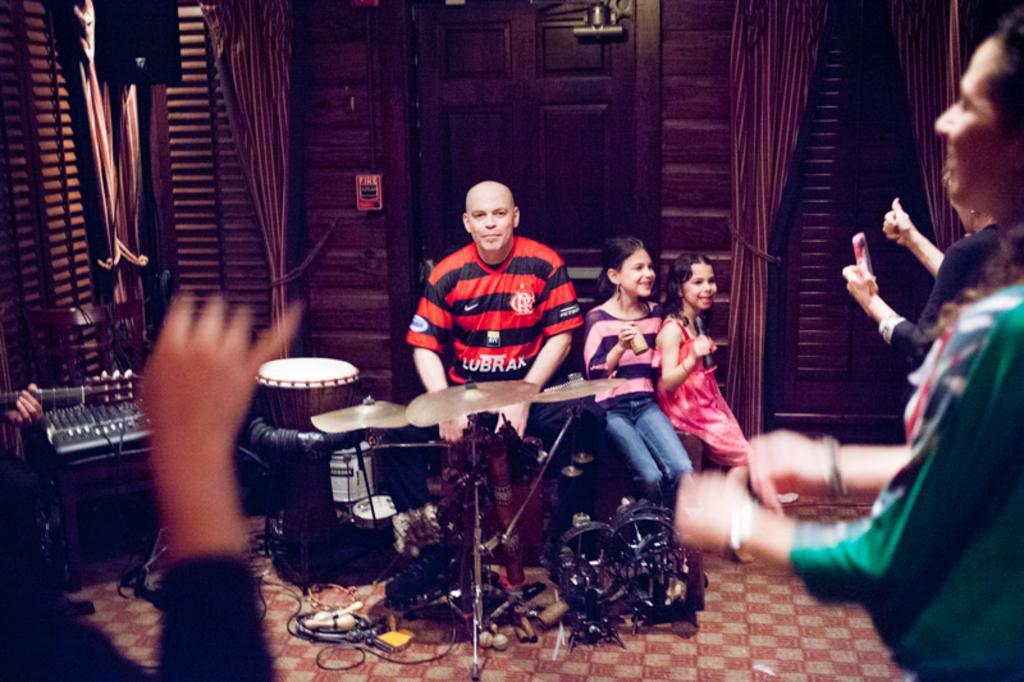How would you summarize this image in a sentence or two? In this picture there are group of people, those who are playing the music, there is a man who is sitting in the middle of the image in front of the drum set, there are two girls who are sitting at the right side of the image, they are laughing at facing to the right side, there are brown curtains around the image and there is a big door behind the front person in the image and there are different types of music instruments in the image. 